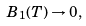Convert formula to latex. <formula><loc_0><loc_0><loc_500><loc_500>B _ { 1 } ( T ) \rightarrow 0 ,</formula> 